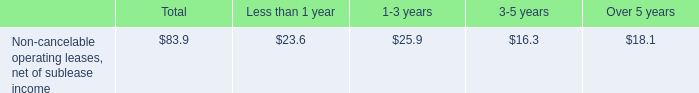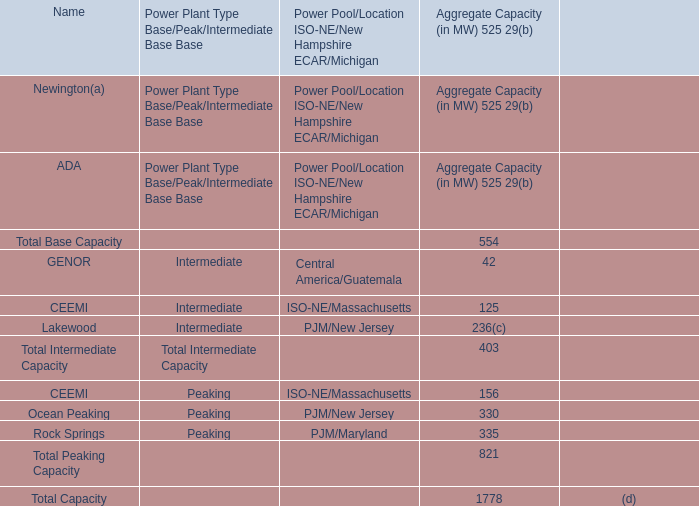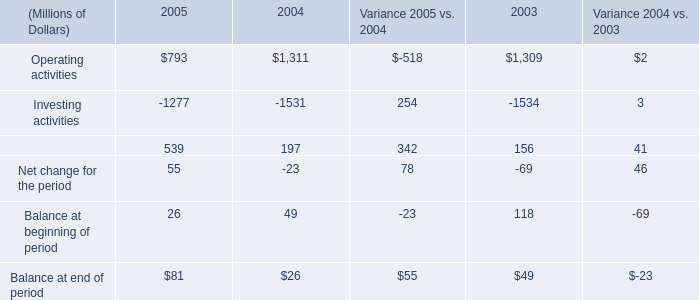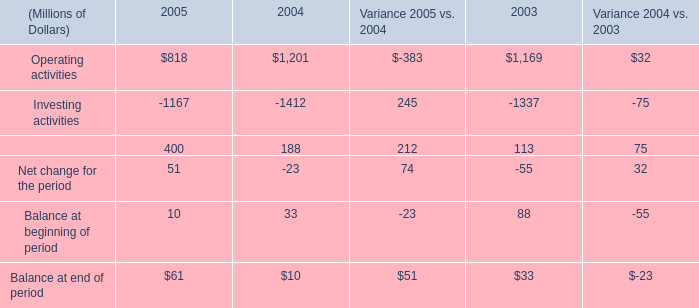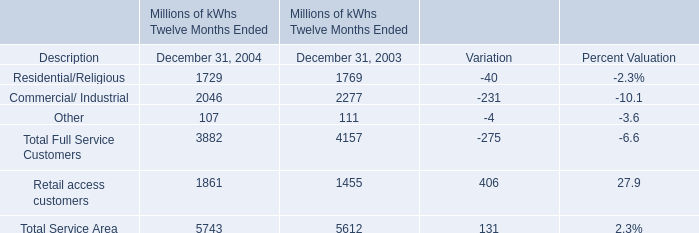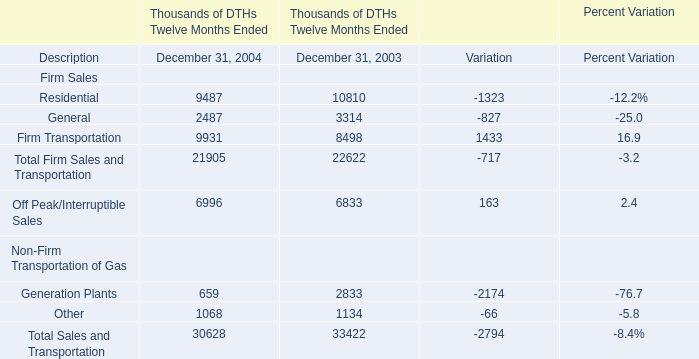What's the difference of Total Service Area between 2004 and 2003? (in million) 
Computations: (5743 - 5612)
Answer: 131.0. 